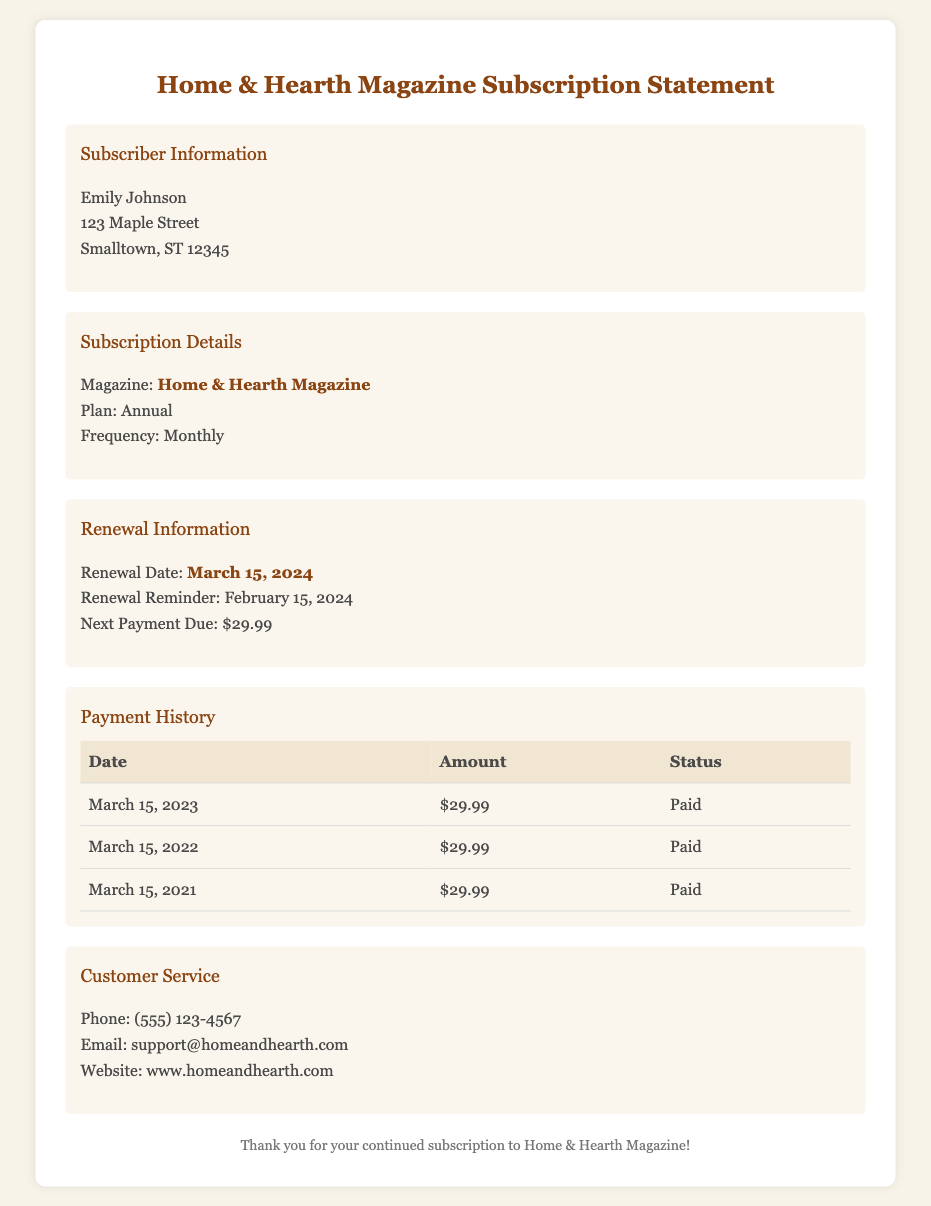What is the subscriber's name? The subscriber's name is mentioned in the Subscriber Information section as Emily Johnson.
Answer: Emily Johnson When is the renewal date? The renewal date is provided in the Renewal Information section. It states March 15, 2024.
Answer: March 15, 2024 What is the amount due for the next payment? The next payment due amount is explicitly stated in the Renewal Information section as $29.99.
Answer: $29.99 How many payments have been made according to the payment history? The payment history shows three entries for payments made on March 15 for the years 2021, 2022, and 2023.
Answer: Three What is the frequency of the subscription plan? The frequency of the subscription plan is stated in the Subscription Details section as Monthly.
Answer: Monthly What is the renewal reminder date? The renewal reminder date is mentioned in the Renewal Information section as February 15, 2024.
Answer: February 15, 2024 What is the customer service phone number? The customer service phone number is stated in the Customer Service section as (555) 123-4567.
Answer: (555) 123-4567 What type of subscription plan is Emily on? The type of subscription plan is specified in the Subscription Details section as Annual.
Answer: Annual 